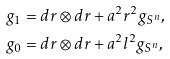Convert formula to latex. <formula><loc_0><loc_0><loc_500><loc_500>g _ { 1 } & = d r \otimes d r + a ^ { 2 } r ^ { 2 } g _ { S ^ { n } } , \\ g _ { 0 } & = d r \otimes d r + a ^ { 2 } l ^ { 2 } g _ { S ^ { n } } ,</formula> 